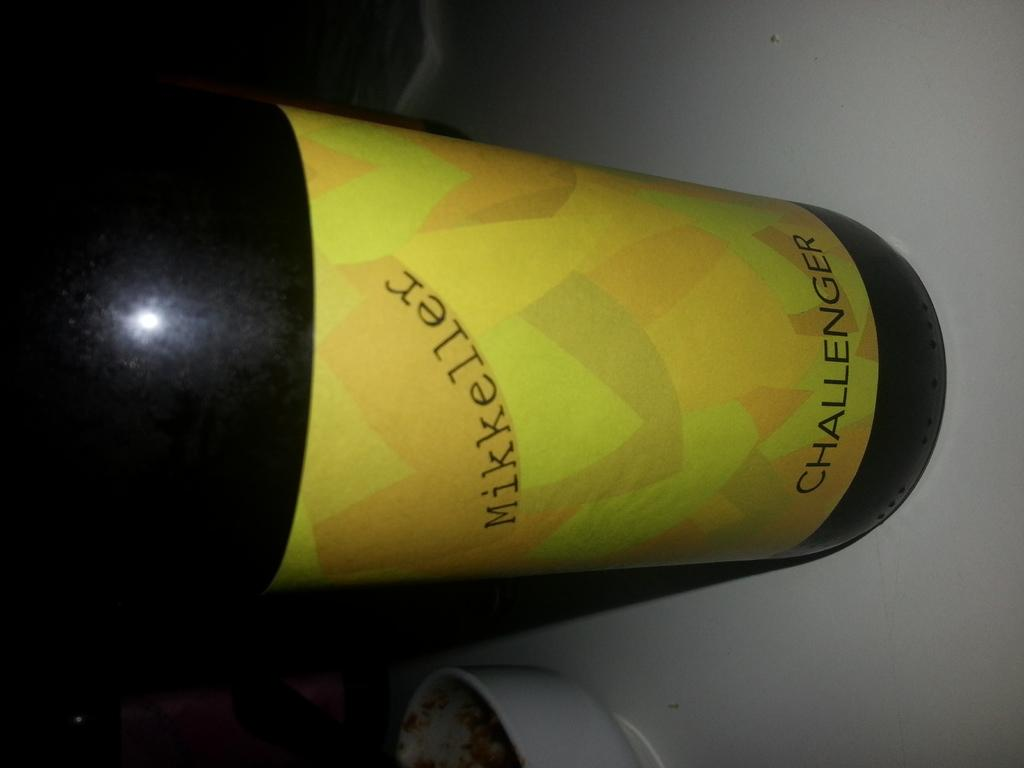<image>
Relay a brief, clear account of the picture shown. The type of drink is a Challenger from Mikkeller 